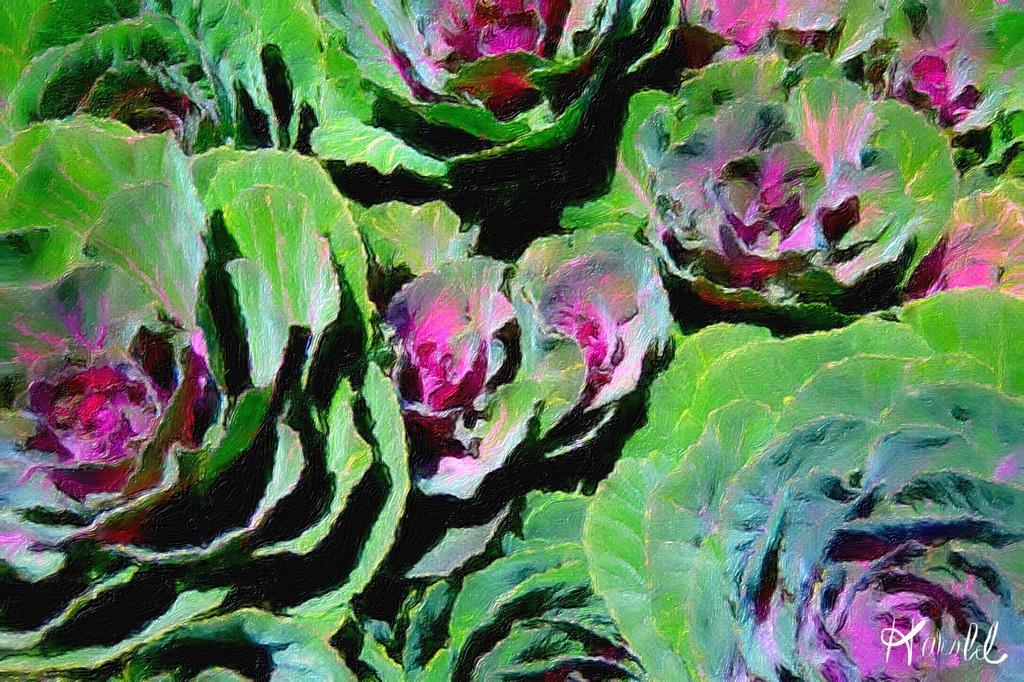What type of living organisms can be seen in the image? Plants can be seen in the image. What is the color of the plants in the image? The plants have a pink color. How long does it take for the plants to grow a rail in the image? There is no rail present in the image, and plants do not grow rails. 